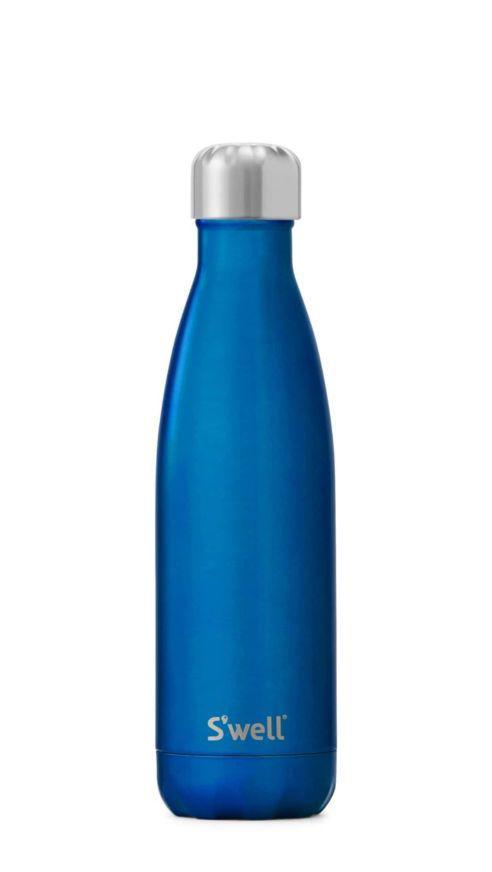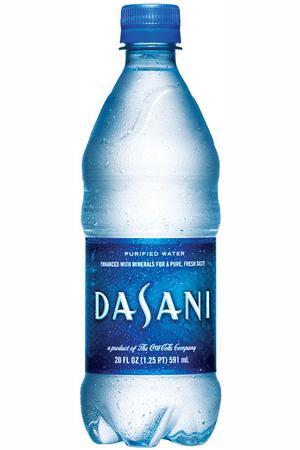The first image is the image on the left, the second image is the image on the right. Given the left and right images, does the statement "The image on the left contains a dark blue bottle." hold true? Answer yes or no. Yes. 